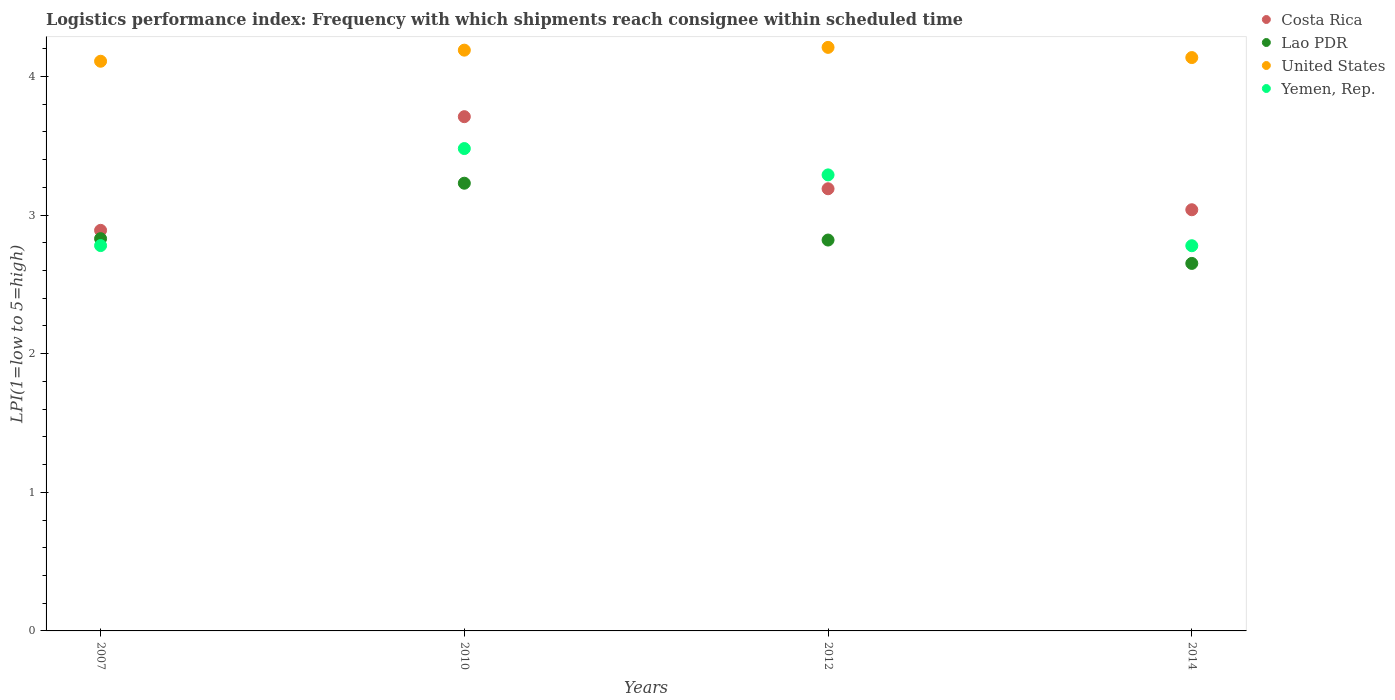Is the number of dotlines equal to the number of legend labels?
Ensure brevity in your answer.  Yes. What is the logistics performance index in Lao PDR in 2012?
Offer a very short reply. 2.82. Across all years, what is the maximum logistics performance index in Lao PDR?
Your answer should be compact. 3.23. Across all years, what is the minimum logistics performance index in Lao PDR?
Your answer should be very brief. 2.65. In which year was the logistics performance index in Lao PDR maximum?
Give a very brief answer. 2010. What is the total logistics performance index in Costa Rica in the graph?
Offer a very short reply. 12.83. What is the difference between the logistics performance index in Costa Rica in 2007 and that in 2010?
Your answer should be very brief. -0.82. What is the difference between the logistics performance index in Yemen, Rep. in 2014 and the logistics performance index in United States in 2007?
Offer a very short reply. -1.33. What is the average logistics performance index in Yemen, Rep. per year?
Ensure brevity in your answer.  3.08. In the year 2010, what is the difference between the logistics performance index in Yemen, Rep. and logistics performance index in United States?
Your response must be concise. -0.71. What is the ratio of the logistics performance index in Lao PDR in 2007 to that in 2010?
Your answer should be compact. 0.88. Is the logistics performance index in Lao PDR in 2007 less than that in 2012?
Keep it short and to the point. No. Is the difference between the logistics performance index in Yemen, Rep. in 2007 and 2012 greater than the difference between the logistics performance index in United States in 2007 and 2012?
Offer a very short reply. No. What is the difference between the highest and the second highest logistics performance index in United States?
Keep it short and to the point. 0.02. What is the difference between the highest and the lowest logistics performance index in Lao PDR?
Your answer should be compact. 0.58. Is the sum of the logistics performance index in Yemen, Rep. in 2007 and 2012 greater than the maximum logistics performance index in Lao PDR across all years?
Your response must be concise. Yes. Is it the case that in every year, the sum of the logistics performance index in United States and logistics performance index in Costa Rica  is greater than the sum of logistics performance index in Lao PDR and logistics performance index in Yemen, Rep.?
Keep it short and to the point. No. Is it the case that in every year, the sum of the logistics performance index in United States and logistics performance index in Costa Rica  is greater than the logistics performance index in Yemen, Rep.?
Your response must be concise. Yes. Does the logistics performance index in Lao PDR monotonically increase over the years?
Your response must be concise. No. How many dotlines are there?
Keep it short and to the point. 4. What is the difference between two consecutive major ticks on the Y-axis?
Ensure brevity in your answer.  1. Does the graph contain any zero values?
Keep it short and to the point. No. Where does the legend appear in the graph?
Make the answer very short. Top right. How many legend labels are there?
Offer a terse response. 4. How are the legend labels stacked?
Your response must be concise. Vertical. What is the title of the graph?
Provide a short and direct response. Logistics performance index: Frequency with which shipments reach consignee within scheduled time. What is the label or title of the X-axis?
Provide a short and direct response. Years. What is the label or title of the Y-axis?
Provide a succinct answer. LPI(1=low to 5=high). What is the LPI(1=low to 5=high) of Costa Rica in 2007?
Give a very brief answer. 2.89. What is the LPI(1=low to 5=high) in Lao PDR in 2007?
Ensure brevity in your answer.  2.83. What is the LPI(1=low to 5=high) of United States in 2007?
Offer a terse response. 4.11. What is the LPI(1=low to 5=high) of Yemen, Rep. in 2007?
Your answer should be compact. 2.78. What is the LPI(1=low to 5=high) in Costa Rica in 2010?
Make the answer very short. 3.71. What is the LPI(1=low to 5=high) in Lao PDR in 2010?
Ensure brevity in your answer.  3.23. What is the LPI(1=low to 5=high) in United States in 2010?
Your response must be concise. 4.19. What is the LPI(1=low to 5=high) of Yemen, Rep. in 2010?
Make the answer very short. 3.48. What is the LPI(1=low to 5=high) of Costa Rica in 2012?
Make the answer very short. 3.19. What is the LPI(1=low to 5=high) in Lao PDR in 2012?
Your response must be concise. 2.82. What is the LPI(1=low to 5=high) in United States in 2012?
Ensure brevity in your answer.  4.21. What is the LPI(1=low to 5=high) of Yemen, Rep. in 2012?
Your answer should be very brief. 3.29. What is the LPI(1=low to 5=high) in Costa Rica in 2014?
Keep it short and to the point. 3.04. What is the LPI(1=low to 5=high) in Lao PDR in 2014?
Make the answer very short. 2.65. What is the LPI(1=low to 5=high) in United States in 2014?
Ensure brevity in your answer.  4.14. What is the LPI(1=low to 5=high) of Yemen, Rep. in 2014?
Make the answer very short. 2.78. Across all years, what is the maximum LPI(1=low to 5=high) of Costa Rica?
Provide a short and direct response. 3.71. Across all years, what is the maximum LPI(1=low to 5=high) in Lao PDR?
Give a very brief answer. 3.23. Across all years, what is the maximum LPI(1=low to 5=high) in United States?
Ensure brevity in your answer.  4.21. Across all years, what is the maximum LPI(1=low to 5=high) in Yemen, Rep.?
Your answer should be compact. 3.48. Across all years, what is the minimum LPI(1=low to 5=high) of Costa Rica?
Make the answer very short. 2.89. Across all years, what is the minimum LPI(1=low to 5=high) in Lao PDR?
Give a very brief answer. 2.65. Across all years, what is the minimum LPI(1=low to 5=high) in United States?
Your answer should be compact. 4.11. Across all years, what is the minimum LPI(1=low to 5=high) of Yemen, Rep.?
Make the answer very short. 2.78. What is the total LPI(1=low to 5=high) of Costa Rica in the graph?
Your answer should be compact. 12.83. What is the total LPI(1=low to 5=high) in Lao PDR in the graph?
Your answer should be very brief. 11.53. What is the total LPI(1=low to 5=high) in United States in the graph?
Give a very brief answer. 16.65. What is the total LPI(1=low to 5=high) in Yemen, Rep. in the graph?
Your answer should be very brief. 12.33. What is the difference between the LPI(1=low to 5=high) of Costa Rica in 2007 and that in 2010?
Make the answer very short. -0.82. What is the difference between the LPI(1=low to 5=high) in United States in 2007 and that in 2010?
Offer a terse response. -0.08. What is the difference between the LPI(1=low to 5=high) in Yemen, Rep. in 2007 and that in 2010?
Provide a short and direct response. -0.7. What is the difference between the LPI(1=low to 5=high) of Lao PDR in 2007 and that in 2012?
Your answer should be very brief. 0.01. What is the difference between the LPI(1=low to 5=high) in Yemen, Rep. in 2007 and that in 2012?
Provide a short and direct response. -0.51. What is the difference between the LPI(1=low to 5=high) in Costa Rica in 2007 and that in 2014?
Provide a succinct answer. -0.15. What is the difference between the LPI(1=low to 5=high) in Lao PDR in 2007 and that in 2014?
Make the answer very short. 0.18. What is the difference between the LPI(1=low to 5=high) in United States in 2007 and that in 2014?
Provide a short and direct response. -0.03. What is the difference between the LPI(1=low to 5=high) in Yemen, Rep. in 2007 and that in 2014?
Your answer should be compact. 0. What is the difference between the LPI(1=low to 5=high) of Costa Rica in 2010 and that in 2012?
Offer a terse response. 0.52. What is the difference between the LPI(1=low to 5=high) of Lao PDR in 2010 and that in 2012?
Your answer should be very brief. 0.41. What is the difference between the LPI(1=low to 5=high) in United States in 2010 and that in 2012?
Offer a very short reply. -0.02. What is the difference between the LPI(1=low to 5=high) in Yemen, Rep. in 2010 and that in 2012?
Your response must be concise. 0.19. What is the difference between the LPI(1=low to 5=high) of Costa Rica in 2010 and that in 2014?
Offer a very short reply. 0.67. What is the difference between the LPI(1=low to 5=high) of Lao PDR in 2010 and that in 2014?
Offer a terse response. 0.58. What is the difference between the LPI(1=low to 5=high) of United States in 2010 and that in 2014?
Give a very brief answer. 0.05. What is the difference between the LPI(1=low to 5=high) of Yemen, Rep. in 2010 and that in 2014?
Ensure brevity in your answer.  0.7. What is the difference between the LPI(1=low to 5=high) of Costa Rica in 2012 and that in 2014?
Your answer should be very brief. 0.15. What is the difference between the LPI(1=low to 5=high) of Lao PDR in 2012 and that in 2014?
Offer a very short reply. 0.17. What is the difference between the LPI(1=low to 5=high) in United States in 2012 and that in 2014?
Offer a terse response. 0.07. What is the difference between the LPI(1=low to 5=high) in Yemen, Rep. in 2012 and that in 2014?
Make the answer very short. 0.51. What is the difference between the LPI(1=low to 5=high) of Costa Rica in 2007 and the LPI(1=low to 5=high) of Lao PDR in 2010?
Ensure brevity in your answer.  -0.34. What is the difference between the LPI(1=low to 5=high) of Costa Rica in 2007 and the LPI(1=low to 5=high) of United States in 2010?
Offer a terse response. -1.3. What is the difference between the LPI(1=low to 5=high) of Costa Rica in 2007 and the LPI(1=low to 5=high) of Yemen, Rep. in 2010?
Provide a short and direct response. -0.59. What is the difference between the LPI(1=low to 5=high) in Lao PDR in 2007 and the LPI(1=low to 5=high) in United States in 2010?
Offer a very short reply. -1.36. What is the difference between the LPI(1=low to 5=high) in Lao PDR in 2007 and the LPI(1=low to 5=high) in Yemen, Rep. in 2010?
Keep it short and to the point. -0.65. What is the difference between the LPI(1=low to 5=high) of United States in 2007 and the LPI(1=low to 5=high) of Yemen, Rep. in 2010?
Your response must be concise. 0.63. What is the difference between the LPI(1=low to 5=high) in Costa Rica in 2007 and the LPI(1=low to 5=high) in Lao PDR in 2012?
Offer a terse response. 0.07. What is the difference between the LPI(1=low to 5=high) in Costa Rica in 2007 and the LPI(1=low to 5=high) in United States in 2012?
Ensure brevity in your answer.  -1.32. What is the difference between the LPI(1=low to 5=high) in Costa Rica in 2007 and the LPI(1=low to 5=high) in Yemen, Rep. in 2012?
Make the answer very short. -0.4. What is the difference between the LPI(1=low to 5=high) in Lao PDR in 2007 and the LPI(1=low to 5=high) in United States in 2012?
Keep it short and to the point. -1.38. What is the difference between the LPI(1=low to 5=high) of Lao PDR in 2007 and the LPI(1=low to 5=high) of Yemen, Rep. in 2012?
Your answer should be compact. -0.46. What is the difference between the LPI(1=low to 5=high) in United States in 2007 and the LPI(1=low to 5=high) in Yemen, Rep. in 2012?
Ensure brevity in your answer.  0.82. What is the difference between the LPI(1=low to 5=high) in Costa Rica in 2007 and the LPI(1=low to 5=high) in Lao PDR in 2014?
Offer a terse response. 0.24. What is the difference between the LPI(1=low to 5=high) in Costa Rica in 2007 and the LPI(1=low to 5=high) in United States in 2014?
Offer a very short reply. -1.25. What is the difference between the LPI(1=low to 5=high) of Costa Rica in 2007 and the LPI(1=low to 5=high) of Yemen, Rep. in 2014?
Your answer should be very brief. 0.11. What is the difference between the LPI(1=low to 5=high) of Lao PDR in 2007 and the LPI(1=low to 5=high) of United States in 2014?
Offer a very short reply. -1.31. What is the difference between the LPI(1=low to 5=high) in Lao PDR in 2007 and the LPI(1=low to 5=high) in Yemen, Rep. in 2014?
Your response must be concise. 0.05. What is the difference between the LPI(1=low to 5=high) of United States in 2007 and the LPI(1=low to 5=high) of Yemen, Rep. in 2014?
Provide a short and direct response. 1.33. What is the difference between the LPI(1=low to 5=high) in Costa Rica in 2010 and the LPI(1=low to 5=high) in Lao PDR in 2012?
Offer a terse response. 0.89. What is the difference between the LPI(1=low to 5=high) in Costa Rica in 2010 and the LPI(1=low to 5=high) in Yemen, Rep. in 2012?
Give a very brief answer. 0.42. What is the difference between the LPI(1=low to 5=high) in Lao PDR in 2010 and the LPI(1=low to 5=high) in United States in 2012?
Provide a succinct answer. -0.98. What is the difference between the LPI(1=low to 5=high) of Lao PDR in 2010 and the LPI(1=low to 5=high) of Yemen, Rep. in 2012?
Provide a short and direct response. -0.06. What is the difference between the LPI(1=low to 5=high) of United States in 2010 and the LPI(1=low to 5=high) of Yemen, Rep. in 2012?
Provide a short and direct response. 0.9. What is the difference between the LPI(1=low to 5=high) of Costa Rica in 2010 and the LPI(1=low to 5=high) of Lao PDR in 2014?
Make the answer very short. 1.06. What is the difference between the LPI(1=low to 5=high) in Costa Rica in 2010 and the LPI(1=low to 5=high) in United States in 2014?
Ensure brevity in your answer.  -0.43. What is the difference between the LPI(1=low to 5=high) in Lao PDR in 2010 and the LPI(1=low to 5=high) in United States in 2014?
Your response must be concise. -0.91. What is the difference between the LPI(1=low to 5=high) of Lao PDR in 2010 and the LPI(1=low to 5=high) of Yemen, Rep. in 2014?
Give a very brief answer. 0.45. What is the difference between the LPI(1=low to 5=high) of United States in 2010 and the LPI(1=low to 5=high) of Yemen, Rep. in 2014?
Your response must be concise. 1.41. What is the difference between the LPI(1=low to 5=high) of Costa Rica in 2012 and the LPI(1=low to 5=high) of Lao PDR in 2014?
Your answer should be very brief. 0.54. What is the difference between the LPI(1=low to 5=high) of Costa Rica in 2012 and the LPI(1=low to 5=high) of United States in 2014?
Your response must be concise. -0.95. What is the difference between the LPI(1=low to 5=high) of Costa Rica in 2012 and the LPI(1=low to 5=high) of Yemen, Rep. in 2014?
Offer a very short reply. 0.41. What is the difference between the LPI(1=low to 5=high) in Lao PDR in 2012 and the LPI(1=low to 5=high) in United States in 2014?
Ensure brevity in your answer.  -1.32. What is the difference between the LPI(1=low to 5=high) of Lao PDR in 2012 and the LPI(1=low to 5=high) of Yemen, Rep. in 2014?
Your answer should be compact. 0.04. What is the difference between the LPI(1=low to 5=high) of United States in 2012 and the LPI(1=low to 5=high) of Yemen, Rep. in 2014?
Offer a terse response. 1.43. What is the average LPI(1=low to 5=high) of Costa Rica per year?
Provide a succinct answer. 3.21. What is the average LPI(1=low to 5=high) in Lao PDR per year?
Provide a short and direct response. 2.88. What is the average LPI(1=low to 5=high) of United States per year?
Give a very brief answer. 4.16. What is the average LPI(1=low to 5=high) in Yemen, Rep. per year?
Provide a short and direct response. 3.08. In the year 2007, what is the difference between the LPI(1=low to 5=high) of Costa Rica and LPI(1=low to 5=high) of United States?
Offer a terse response. -1.22. In the year 2007, what is the difference between the LPI(1=low to 5=high) of Costa Rica and LPI(1=low to 5=high) of Yemen, Rep.?
Offer a terse response. 0.11. In the year 2007, what is the difference between the LPI(1=low to 5=high) in Lao PDR and LPI(1=low to 5=high) in United States?
Your response must be concise. -1.28. In the year 2007, what is the difference between the LPI(1=low to 5=high) in United States and LPI(1=low to 5=high) in Yemen, Rep.?
Your answer should be very brief. 1.33. In the year 2010, what is the difference between the LPI(1=low to 5=high) of Costa Rica and LPI(1=low to 5=high) of Lao PDR?
Offer a very short reply. 0.48. In the year 2010, what is the difference between the LPI(1=low to 5=high) of Costa Rica and LPI(1=low to 5=high) of United States?
Provide a succinct answer. -0.48. In the year 2010, what is the difference between the LPI(1=low to 5=high) of Costa Rica and LPI(1=low to 5=high) of Yemen, Rep.?
Keep it short and to the point. 0.23. In the year 2010, what is the difference between the LPI(1=low to 5=high) of Lao PDR and LPI(1=low to 5=high) of United States?
Give a very brief answer. -0.96. In the year 2010, what is the difference between the LPI(1=low to 5=high) of Lao PDR and LPI(1=low to 5=high) of Yemen, Rep.?
Make the answer very short. -0.25. In the year 2010, what is the difference between the LPI(1=low to 5=high) of United States and LPI(1=low to 5=high) of Yemen, Rep.?
Your answer should be compact. 0.71. In the year 2012, what is the difference between the LPI(1=low to 5=high) in Costa Rica and LPI(1=low to 5=high) in Lao PDR?
Give a very brief answer. 0.37. In the year 2012, what is the difference between the LPI(1=low to 5=high) of Costa Rica and LPI(1=low to 5=high) of United States?
Your response must be concise. -1.02. In the year 2012, what is the difference between the LPI(1=low to 5=high) of Costa Rica and LPI(1=low to 5=high) of Yemen, Rep.?
Offer a terse response. -0.1. In the year 2012, what is the difference between the LPI(1=low to 5=high) in Lao PDR and LPI(1=low to 5=high) in United States?
Your answer should be very brief. -1.39. In the year 2012, what is the difference between the LPI(1=low to 5=high) in Lao PDR and LPI(1=low to 5=high) in Yemen, Rep.?
Offer a terse response. -0.47. In the year 2012, what is the difference between the LPI(1=low to 5=high) in United States and LPI(1=low to 5=high) in Yemen, Rep.?
Make the answer very short. 0.92. In the year 2014, what is the difference between the LPI(1=low to 5=high) of Costa Rica and LPI(1=low to 5=high) of Lao PDR?
Your answer should be very brief. 0.39. In the year 2014, what is the difference between the LPI(1=low to 5=high) in Costa Rica and LPI(1=low to 5=high) in United States?
Offer a terse response. -1.1. In the year 2014, what is the difference between the LPI(1=low to 5=high) in Costa Rica and LPI(1=low to 5=high) in Yemen, Rep.?
Your answer should be very brief. 0.26. In the year 2014, what is the difference between the LPI(1=low to 5=high) of Lao PDR and LPI(1=low to 5=high) of United States?
Make the answer very short. -1.49. In the year 2014, what is the difference between the LPI(1=low to 5=high) of Lao PDR and LPI(1=low to 5=high) of Yemen, Rep.?
Your answer should be compact. -0.13. In the year 2014, what is the difference between the LPI(1=low to 5=high) of United States and LPI(1=low to 5=high) of Yemen, Rep.?
Offer a terse response. 1.36. What is the ratio of the LPI(1=low to 5=high) of Costa Rica in 2007 to that in 2010?
Your response must be concise. 0.78. What is the ratio of the LPI(1=low to 5=high) of Lao PDR in 2007 to that in 2010?
Your answer should be very brief. 0.88. What is the ratio of the LPI(1=low to 5=high) of United States in 2007 to that in 2010?
Offer a very short reply. 0.98. What is the ratio of the LPI(1=low to 5=high) of Yemen, Rep. in 2007 to that in 2010?
Make the answer very short. 0.8. What is the ratio of the LPI(1=low to 5=high) in Costa Rica in 2007 to that in 2012?
Your answer should be compact. 0.91. What is the ratio of the LPI(1=low to 5=high) in Lao PDR in 2007 to that in 2012?
Your response must be concise. 1. What is the ratio of the LPI(1=low to 5=high) of United States in 2007 to that in 2012?
Give a very brief answer. 0.98. What is the ratio of the LPI(1=low to 5=high) in Yemen, Rep. in 2007 to that in 2012?
Make the answer very short. 0.84. What is the ratio of the LPI(1=low to 5=high) in Costa Rica in 2007 to that in 2014?
Your answer should be compact. 0.95. What is the ratio of the LPI(1=low to 5=high) in Lao PDR in 2007 to that in 2014?
Provide a short and direct response. 1.07. What is the ratio of the LPI(1=low to 5=high) of Costa Rica in 2010 to that in 2012?
Your answer should be compact. 1.16. What is the ratio of the LPI(1=low to 5=high) in Lao PDR in 2010 to that in 2012?
Offer a very short reply. 1.15. What is the ratio of the LPI(1=low to 5=high) in Yemen, Rep. in 2010 to that in 2012?
Provide a succinct answer. 1.06. What is the ratio of the LPI(1=low to 5=high) in Costa Rica in 2010 to that in 2014?
Your response must be concise. 1.22. What is the ratio of the LPI(1=low to 5=high) in Lao PDR in 2010 to that in 2014?
Offer a very short reply. 1.22. What is the ratio of the LPI(1=low to 5=high) in United States in 2010 to that in 2014?
Keep it short and to the point. 1.01. What is the ratio of the LPI(1=low to 5=high) in Yemen, Rep. in 2010 to that in 2014?
Ensure brevity in your answer.  1.25. What is the ratio of the LPI(1=low to 5=high) of Costa Rica in 2012 to that in 2014?
Your answer should be very brief. 1.05. What is the ratio of the LPI(1=low to 5=high) of Lao PDR in 2012 to that in 2014?
Provide a succinct answer. 1.06. What is the ratio of the LPI(1=low to 5=high) of United States in 2012 to that in 2014?
Your answer should be compact. 1.02. What is the ratio of the LPI(1=low to 5=high) of Yemen, Rep. in 2012 to that in 2014?
Keep it short and to the point. 1.18. What is the difference between the highest and the second highest LPI(1=low to 5=high) of Costa Rica?
Your answer should be very brief. 0.52. What is the difference between the highest and the second highest LPI(1=low to 5=high) in Lao PDR?
Ensure brevity in your answer.  0.4. What is the difference between the highest and the second highest LPI(1=low to 5=high) of United States?
Provide a short and direct response. 0.02. What is the difference between the highest and the second highest LPI(1=low to 5=high) in Yemen, Rep.?
Your response must be concise. 0.19. What is the difference between the highest and the lowest LPI(1=low to 5=high) in Costa Rica?
Offer a terse response. 0.82. What is the difference between the highest and the lowest LPI(1=low to 5=high) of Lao PDR?
Provide a short and direct response. 0.58. What is the difference between the highest and the lowest LPI(1=low to 5=high) in Yemen, Rep.?
Provide a short and direct response. 0.7. 